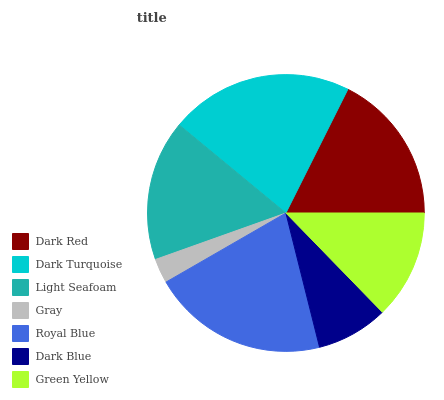Is Gray the minimum?
Answer yes or no. Yes. Is Dark Turquoise the maximum?
Answer yes or no. Yes. Is Light Seafoam the minimum?
Answer yes or no. No. Is Light Seafoam the maximum?
Answer yes or no. No. Is Dark Turquoise greater than Light Seafoam?
Answer yes or no. Yes. Is Light Seafoam less than Dark Turquoise?
Answer yes or no. Yes. Is Light Seafoam greater than Dark Turquoise?
Answer yes or no. No. Is Dark Turquoise less than Light Seafoam?
Answer yes or no. No. Is Light Seafoam the high median?
Answer yes or no. Yes. Is Light Seafoam the low median?
Answer yes or no. Yes. Is Gray the high median?
Answer yes or no. No. Is Dark Turquoise the low median?
Answer yes or no. No. 